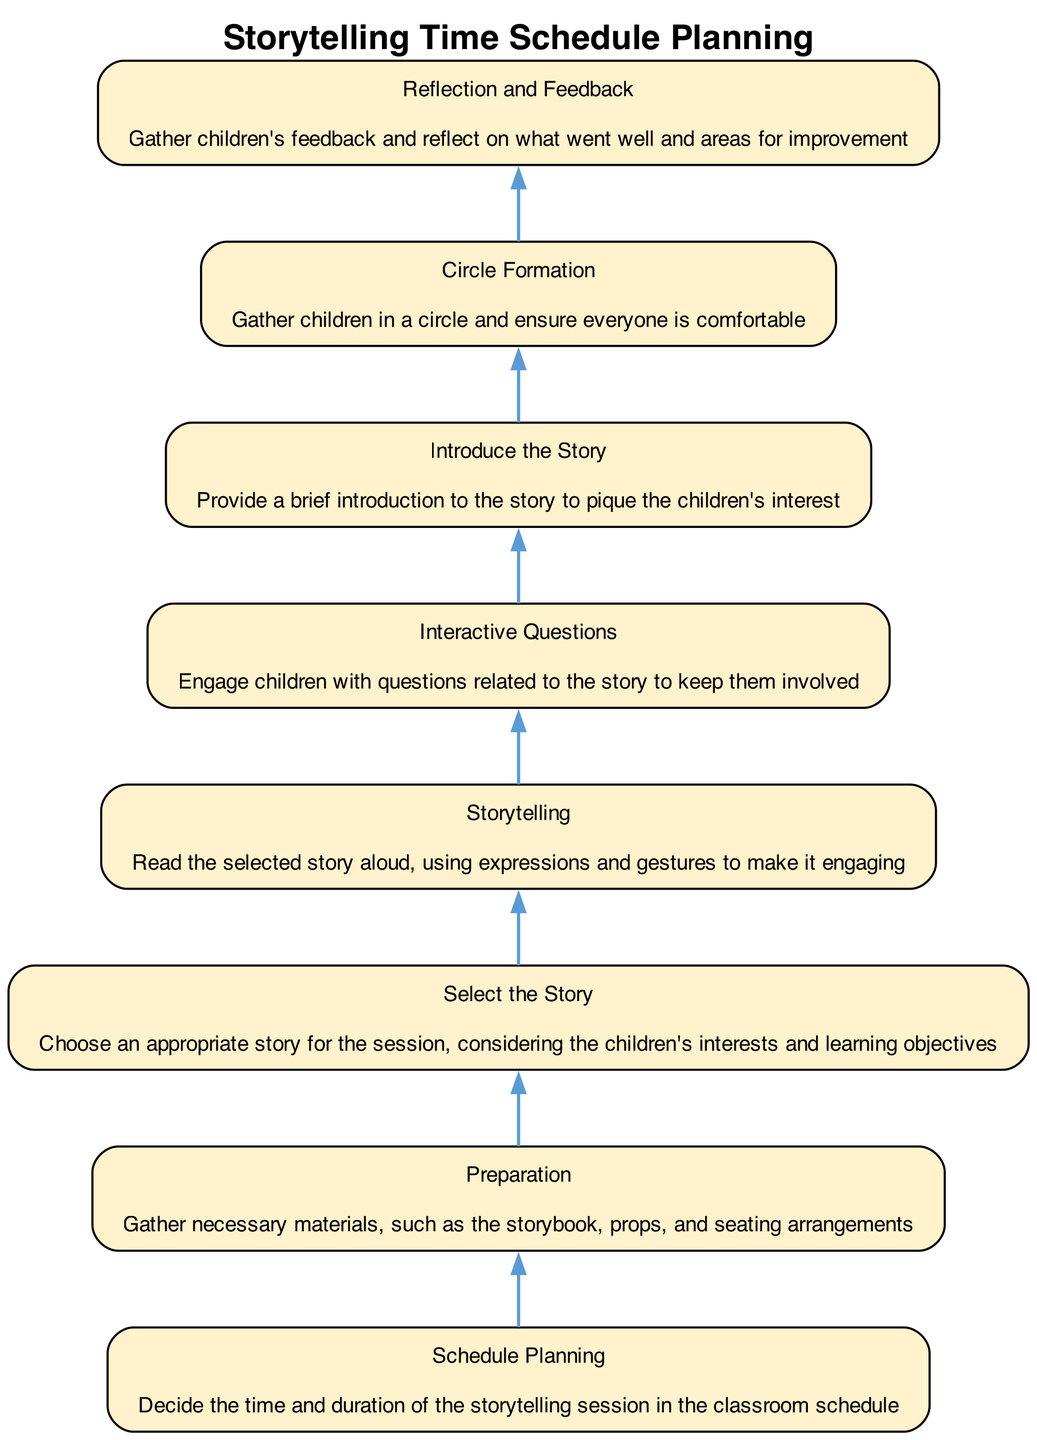What is the first step in the storytelling time schedule? The first step is reflected in the base of the flowchart and is labeled "Schedule Planning," indicating the need to decide the time and duration for the storytelling session.
Answer: Schedule Planning How many nodes are present in the diagram? The diagram includes eight nodes, each representing a distinct step in the storytelling process, as indicated in the provided data.
Answer: Eight What is the last step before "Reflection and Feedback"? The last step before "Reflection and Feedback" is "Circle Formation," which involves gathering children in a circle and ensuring everyone's comfort.
Answer: Circle Formation What materials are needed in the "Preparation" step? "Preparation" involves gathering necessary materials, such as the storybook, props, and seating arrangements, as described under this step.
Answer: Storybook, props, seating arrangements Which step follows "Select the Story"? The step that follows "Select the Story" is "Preparation," indicating that after selecting a story, the next task is to gather materials for storytelling.
Answer: Preparation Which two nodes are primarily concerned with child engagement? The nodes "Storytelling" and "Interactive Questions" focus on child engagement by reading aloud and involving children with related questions.
Answer: Storytelling, Interactive Questions What is the overall purpose of the flowchart? The purpose of the flowchart is to outline the steps for planning a storytelling session, providing a structured approach from selecting a story to gathering feedback afterward.
Answer: Structured storytelling session During which step are children engaged with questions? Children are engaged with questions during the "Interactive Questions" step, where facilitators encourage participation related to the story.
Answer: Interactive Questions 